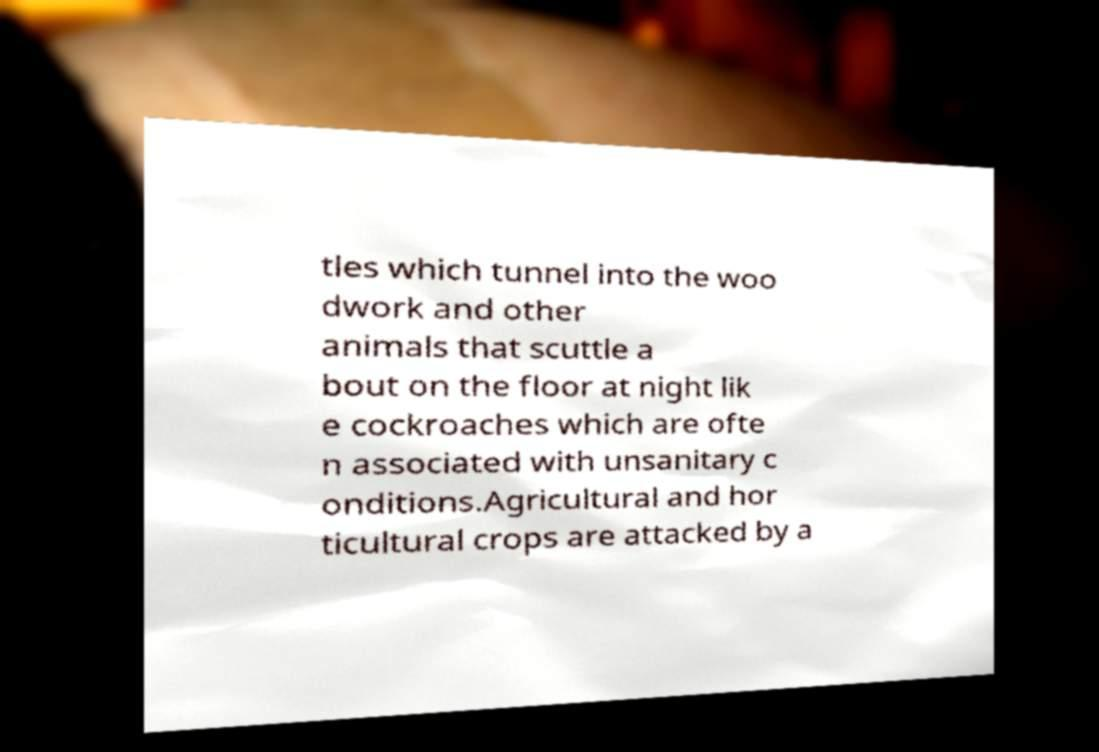Please identify and transcribe the text found in this image. tles which tunnel into the woo dwork and other animals that scuttle a bout on the floor at night lik e cockroaches which are ofte n associated with unsanitary c onditions.Agricultural and hor ticultural crops are attacked by a 